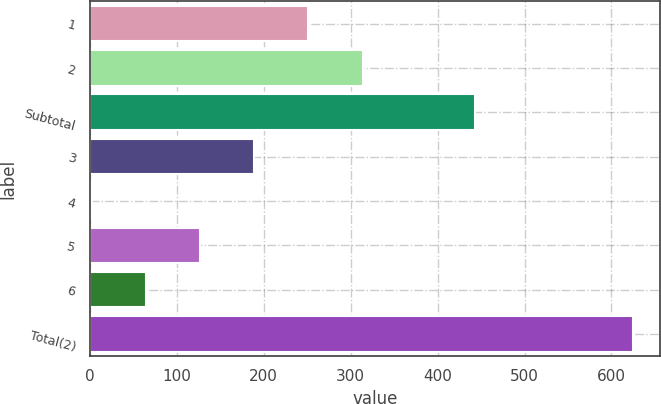Convert chart to OTSL. <chart><loc_0><loc_0><loc_500><loc_500><bar_chart><fcel>1<fcel>2<fcel>Subtotal<fcel>3<fcel>4<fcel>5<fcel>6<fcel>Total(2)<nl><fcel>251.36<fcel>313.64<fcel>443<fcel>189.08<fcel>2.24<fcel>126.8<fcel>64.52<fcel>625<nl></chart> 